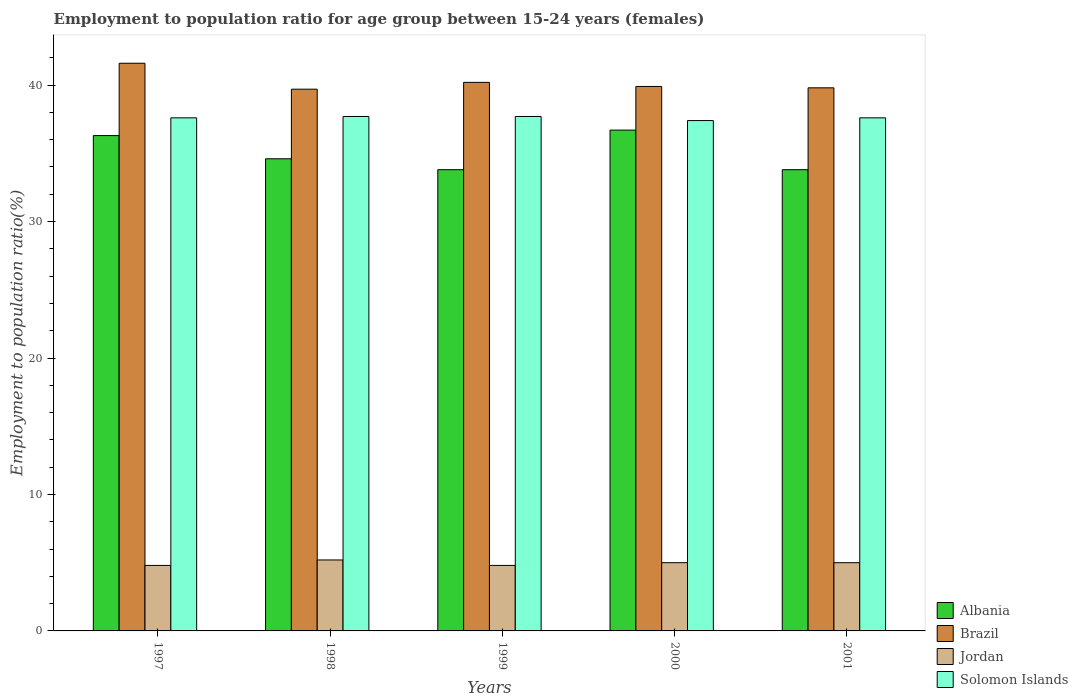How many different coloured bars are there?
Your answer should be very brief. 4. Are the number of bars per tick equal to the number of legend labels?
Your response must be concise. Yes. Are the number of bars on each tick of the X-axis equal?
Your answer should be very brief. Yes. How many bars are there on the 5th tick from the left?
Make the answer very short. 4. How many bars are there on the 3rd tick from the right?
Provide a short and direct response. 4. What is the label of the 3rd group of bars from the left?
Your answer should be compact. 1999. What is the employment to population ratio in Jordan in 1997?
Ensure brevity in your answer.  4.8. Across all years, what is the maximum employment to population ratio in Jordan?
Your answer should be very brief. 5.2. Across all years, what is the minimum employment to population ratio in Jordan?
Your answer should be compact. 4.8. In which year was the employment to population ratio in Jordan maximum?
Give a very brief answer. 1998. What is the total employment to population ratio in Brazil in the graph?
Provide a short and direct response. 201.2. What is the difference between the employment to population ratio in Jordan in 1998 and that in 2001?
Provide a short and direct response. 0.2. What is the difference between the employment to population ratio in Brazil in 2001 and the employment to population ratio in Solomon Islands in 1999?
Make the answer very short. 2.1. What is the average employment to population ratio in Jordan per year?
Offer a very short reply. 4.96. In the year 2001, what is the difference between the employment to population ratio in Jordan and employment to population ratio in Solomon Islands?
Keep it short and to the point. -32.6. What is the ratio of the employment to population ratio in Solomon Islands in 1999 to that in 2000?
Offer a terse response. 1.01. Is the difference between the employment to population ratio in Jordan in 2000 and 2001 greater than the difference between the employment to population ratio in Solomon Islands in 2000 and 2001?
Make the answer very short. Yes. What is the difference between the highest and the second highest employment to population ratio in Albania?
Offer a terse response. 0.4. What is the difference between the highest and the lowest employment to population ratio in Solomon Islands?
Provide a succinct answer. 0.3. In how many years, is the employment to population ratio in Jordan greater than the average employment to population ratio in Jordan taken over all years?
Keep it short and to the point. 3. Is it the case that in every year, the sum of the employment to population ratio in Brazil and employment to population ratio in Albania is greater than the sum of employment to population ratio in Solomon Islands and employment to population ratio in Jordan?
Provide a succinct answer. No. What does the 3rd bar from the right in 1999 represents?
Your response must be concise. Brazil. Is it the case that in every year, the sum of the employment to population ratio in Albania and employment to population ratio in Solomon Islands is greater than the employment to population ratio in Jordan?
Give a very brief answer. Yes. How many bars are there?
Ensure brevity in your answer.  20. Are all the bars in the graph horizontal?
Provide a short and direct response. No. Does the graph contain any zero values?
Provide a succinct answer. No. Does the graph contain grids?
Ensure brevity in your answer.  No. How many legend labels are there?
Ensure brevity in your answer.  4. What is the title of the graph?
Make the answer very short. Employment to population ratio for age group between 15-24 years (females). Does "Congo (Republic)" appear as one of the legend labels in the graph?
Offer a very short reply. No. What is the label or title of the Y-axis?
Provide a short and direct response. Employment to population ratio(%). What is the Employment to population ratio(%) in Albania in 1997?
Keep it short and to the point. 36.3. What is the Employment to population ratio(%) of Brazil in 1997?
Keep it short and to the point. 41.6. What is the Employment to population ratio(%) of Jordan in 1997?
Ensure brevity in your answer.  4.8. What is the Employment to population ratio(%) of Solomon Islands in 1997?
Keep it short and to the point. 37.6. What is the Employment to population ratio(%) of Albania in 1998?
Make the answer very short. 34.6. What is the Employment to population ratio(%) of Brazil in 1998?
Your response must be concise. 39.7. What is the Employment to population ratio(%) in Jordan in 1998?
Provide a succinct answer. 5.2. What is the Employment to population ratio(%) in Solomon Islands in 1998?
Ensure brevity in your answer.  37.7. What is the Employment to population ratio(%) in Albania in 1999?
Your answer should be very brief. 33.8. What is the Employment to population ratio(%) of Brazil in 1999?
Offer a very short reply. 40.2. What is the Employment to population ratio(%) of Jordan in 1999?
Provide a short and direct response. 4.8. What is the Employment to population ratio(%) of Solomon Islands in 1999?
Make the answer very short. 37.7. What is the Employment to population ratio(%) in Albania in 2000?
Provide a short and direct response. 36.7. What is the Employment to population ratio(%) of Brazil in 2000?
Make the answer very short. 39.9. What is the Employment to population ratio(%) of Jordan in 2000?
Your answer should be very brief. 5. What is the Employment to population ratio(%) of Solomon Islands in 2000?
Provide a short and direct response. 37.4. What is the Employment to population ratio(%) in Albania in 2001?
Keep it short and to the point. 33.8. What is the Employment to population ratio(%) in Brazil in 2001?
Give a very brief answer. 39.8. What is the Employment to population ratio(%) of Solomon Islands in 2001?
Provide a succinct answer. 37.6. Across all years, what is the maximum Employment to population ratio(%) of Albania?
Offer a terse response. 36.7. Across all years, what is the maximum Employment to population ratio(%) of Brazil?
Make the answer very short. 41.6. Across all years, what is the maximum Employment to population ratio(%) in Jordan?
Make the answer very short. 5.2. Across all years, what is the maximum Employment to population ratio(%) of Solomon Islands?
Make the answer very short. 37.7. Across all years, what is the minimum Employment to population ratio(%) in Albania?
Keep it short and to the point. 33.8. Across all years, what is the minimum Employment to population ratio(%) in Brazil?
Make the answer very short. 39.7. Across all years, what is the minimum Employment to population ratio(%) of Jordan?
Provide a succinct answer. 4.8. Across all years, what is the minimum Employment to population ratio(%) in Solomon Islands?
Give a very brief answer. 37.4. What is the total Employment to population ratio(%) of Albania in the graph?
Ensure brevity in your answer.  175.2. What is the total Employment to population ratio(%) in Brazil in the graph?
Provide a succinct answer. 201.2. What is the total Employment to population ratio(%) in Jordan in the graph?
Give a very brief answer. 24.8. What is the total Employment to population ratio(%) of Solomon Islands in the graph?
Provide a succinct answer. 188. What is the difference between the Employment to population ratio(%) in Albania in 1997 and that in 1998?
Ensure brevity in your answer.  1.7. What is the difference between the Employment to population ratio(%) in Brazil in 1997 and that in 1998?
Your response must be concise. 1.9. What is the difference between the Employment to population ratio(%) in Jordan in 1997 and that in 1998?
Provide a succinct answer. -0.4. What is the difference between the Employment to population ratio(%) of Solomon Islands in 1997 and that in 1998?
Keep it short and to the point. -0.1. What is the difference between the Employment to population ratio(%) in Albania in 1997 and that in 2000?
Your response must be concise. -0.4. What is the difference between the Employment to population ratio(%) of Brazil in 1997 and that in 2000?
Give a very brief answer. 1.7. What is the difference between the Employment to population ratio(%) of Jordan in 1997 and that in 2000?
Your answer should be very brief. -0.2. What is the difference between the Employment to population ratio(%) of Solomon Islands in 1997 and that in 2000?
Provide a short and direct response. 0.2. What is the difference between the Employment to population ratio(%) of Jordan in 1997 and that in 2001?
Ensure brevity in your answer.  -0.2. What is the difference between the Employment to population ratio(%) of Solomon Islands in 1997 and that in 2001?
Give a very brief answer. 0. What is the difference between the Employment to population ratio(%) in Albania in 1998 and that in 1999?
Offer a very short reply. 0.8. What is the difference between the Employment to population ratio(%) in Brazil in 1998 and that in 1999?
Your answer should be compact. -0.5. What is the difference between the Employment to population ratio(%) in Jordan in 1998 and that in 2000?
Ensure brevity in your answer.  0.2. What is the difference between the Employment to population ratio(%) of Solomon Islands in 1998 and that in 2000?
Offer a terse response. 0.3. What is the difference between the Employment to population ratio(%) of Jordan in 1998 and that in 2001?
Provide a succinct answer. 0.2. What is the difference between the Employment to population ratio(%) in Albania in 1999 and that in 2000?
Your response must be concise. -2.9. What is the difference between the Employment to population ratio(%) of Brazil in 1999 and that in 2000?
Offer a very short reply. 0.3. What is the difference between the Employment to population ratio(%) of Jordan in 1999 and that in 2000?
Offer a terse response. -0.2. What is the difference between the Employment to population ratio(%) of Solomon Islands in 1999 and that in 2000?
Your answer should be compact. 0.3. What is the difference between the Employment to population ratio(%) in Brazil in 2000 and that in 2001?
Make the answer very short. 0.1. What is the difference between the Employment to population ratio(%) of Jordan in 2000 and that in 2001?
Your answer should be compact. 0. What is the difference between the Employment to population ratio(%) in Solomon Islands in 2000 and that in 2001?
Your answer should be very brief. -0.2. What is the difference between the Employment to population ratio(%) in Albania in 1997 and the Employment to population ratio(%) in Jordan in 1998?
Keep it short and to the point. 31.1. What is the difference between the Employment to population ratio(%) of Albania in 1997 and the Employment to population ratio(%) of Solomon Islands in 1998?
Your answer should be very brief. -1.4. What is the difference between the Employment to population ratio(%) of Brazil in 1997 and the Employment to population ratio(%) of Jordan in 1998?
Offer a terse response. 36.4. What is the difference between the Employment to population ratio(%) in Jordan in 1997 and the Employment to population ratio(%) in Solomon Islands in 1998?
Provide a short and direct response. -32.9. What is the difference between the Employment to population ratio(%) in Albania in 1997 and the Employment to population ratio(%) in Brazil in 1999?
Give a very brief answer. -3.9. What is the difference between the Employment to population ratio(%) of Albania in 1997 and the Employment to population ratio(%) of Jordan in 1999?
Provide a succinct answer. 31.5. What is the difference between the Employment to population ratio(%) of Brazil in 1997 and the Employment to population ratio(%) of Jordan in 1999?
Give a very brief answer. 36.8. What is the difference between the Employment to population ratio(%) in Jordan in 1997 and the Employment to population ratio(%) in Solomon Islands in 1999?
Your response must be concise. -32.9. What is the difference between the Employment to population ratio(%) in Albania in 1997 and the Employment to population ratio(%) in Brazil in 2000?
Offer a very short reply. -3.6. What is the difference between the Employment to population ratio(%) of Albania in 1997 and the Employment to population ratio(%) of Jordan in 2000?
Provide a succinct answer. 31.3. What is the difference between the Employment to population ratio(%) of Albania in 1997 and the Employment to population ratio(%) of Solomon Islands in 2000?
Give a very brief answer. -1.1. What is the difference between the Employment to population ratio(%) in Brazil in 1997 and the Employment to population ratio(%) in Jordan in 2000?
Ensure brevity in your answer.  36.6. What is the difference between the Employment to population ratio(%) in Brazil in 1997 and the Employment to population ratio(%) in Solomon Islands in 2000?
Keep it short and to the point. 4.2. What is the difference between the Employment to population ratio(%) of Jordan in 1997 and the Employment to population ratio(%) of Solomon Islands in 2000?
Your answer should be very brief. -32.6. What is the difference between the Employment to population ratio(%) in Albania in 1997 and the Employment to population ratio(%) in Brazil in 2001?
Ensure brevity in your answer.  -3.5. What is the difference between the Employment to population ratio(%) in Albania in 1997 and the Employment to population ratio(%) in Jordan in 2001?
Offer a very short reply. 31.3. What is the difference between the Employment to population ratio(%) in Albania in 1997 and the Employment to population ratio(%) in Solomon Islands in 2001?
Provide a short and direct response. -1.3. What is the difference between the Employment to population ratio(%) of Brazil in 1997 and the Employment to population ratio(%) of Jordan in 2001?
Make the answer very short. 36.6. What is the difference between the Employment to population ratio(%) of Jordan in 1997 and the Employment to population ratio(%) of Solomon Islands in 2001?
Make the answer very short. -32.8. What is the difference between the Employment to population ratio(%) in Albania in 1998 and the Employment to population ratio(%) in Jordan in 1999?
Offer a very short reply. 29.8. What is the difference between the Employment to population ratio(%) in Albania in 1998 and the Employment to population ratio(%) in Solomon Islands in 1999?
Make the answer very short. -3.1. What is the difference between the Employment to population ratio(%) of Brazil in 1998 and the Employment to population ratio(%) of Jordan in 1999?
Provide a short and direct response. 34.9. What is the difference between the Employment to population ratio(%) of Jordan in 1998 and the Employment to population ratio(%) of Solomon Islands in 1999?
Provide a short and direct response. -32.5. What is the difference between the Employment to population ratio(%) of Albania in 1998 and the Employment to population ratio(%) of Jordan in 2000?
Make the answer very short. 29.6. What is the difference between the Employment to population ratio(%) in Brazil in 1998 and the Employment to population ratio(%) in Jordan in 2000?
Offer a very short reply. 34.7. What is the difference between the Employment to population ratio(%) of Brazil in 1998 and the Employment to population ratio(%) of Solomon Islands in 2000?
Give a very brief answer. 2.3. What is the difference between the Employment to population ratio(%) in Jordan in 1998 and the Employment to population ratio(%) in Solomon Islands in 2000?
Ensure brevity in your answer.  -32.2. What is the difference between the Employment to population ratio(%) of Albania in 1998 and the Employment to population ratio(%) of Jordan in 2001?
Your answer should be compact. 29.6. What is the difference between the Employment to population ratio(%) of Albania in 1998 and the Employment to population ratio(%) of Solomon Islands in 2001?
Give a very brief answer. -3. What is the difference between the Employment to population ratio(%) in Brazil in 1998 and the Employment to population ratio(%) in Jordan in 2001?
Offer a very short reply. 34.7. What is the difference between the Employment to population ratio(%) of Brazil in 1998 and the Employment to population ratio(%) of Solomon Islands in 2001?
Give a very brief answer. 2.1. What is the difference between the Employment to population ratio(%) in Jordan in 1998 and the Employment to population ratio(%) in Solomon Islands in 2001?
Offer a terse response. -32.4. What is the difference between the Employment to population ratio(%) in Albania in 1999 and the Employment to population ratio(%) in Jordan in 2000?
Your response must be concise. 28.8. What is the difference between the Employment to population ratio(%) in Albania in 1999 and the Employment to population ratio(%) in Solomon Islands in 2000?
Provide a succinct answer. -3.6. What is the difference between the Employment to population ratio(%) of Brazil in 1999 and the Employment to population ratio(%) of Jordan in 2000?
Your answer should be very brief. 35.2. What is the difference between the Employment to population ratio(%) of Jordan in 1999 and the Employment to population ratio(%) of Solomon Islands in 2000?
Give a very brief answer. -32.6. What is the difference between the Employment to population ratio(%) in Albania in 1999 and the Employment to population ratio(%) in Brazil in 2001?
Give a very brief answer. -6. What is the difference between the Employment to population ratio(%) in Albania in 1999 and the Employment to population ratio(%) in Jordan in 2001?
Provide a succinct answer. 28.8. What is the difference between the Employment to population ratio(%) in Brazil in 1999 and the Employment to population ratio(%) in Jordan in 2001?
Offer a terse response. 35.2. What is the difference between the Employment to population ratio(%) in Jordan in 1999 and the Employment to population ratio(%) in Solomon Islands in 2001?
Your answer should be very brief. -32.8. What is the difference between the Employment to population ratio(%) in Albania in 2000 and the Employment to population ratio(%) in Jordan in 2001?
Your answer should be compact. 31.7. What is the difference between the Employment to population ratio(%) in Albania in 2000 and the Employment to population ratio(%) in Solomon Islands in 2001?
Offer a very short reply. -0.9. What is the difference between the Employment to population ratio(%) in Brazil in 2000 and the Employment to population ratio(%) in Jordan in 2001?
Offer a terse response. 34.9. What is the difference between the Employment to population ratio(%) in Jordan in 2000 and the Employment to population ratio(%) in Solomon Islands in 2001?
Your answer should be very brief. -32.6. What is the average Employment to population ratio(%) in Albania per year?
Provide a succinct answer. 35.04. What is the average Employment to population ratio(%) of Brazil per year?
Provide a short and direct response. 40.24. What is the average Employment to population ratio(%) of Jordan per year?
Offer a terse response. 4.96. What is the average Employment to population ratio(%) in Solomon Islands per year?
Ensure brevity in your answer.  37.6. In the year 1997, what is the difference between the Employment to population ratio(%) in Albania and Employment to population ratio(%) in Jordan?
Give a very brief answer. 31.5. In the year 1997, what is the difference between the Employment to population ratio(%) in Albania and Employment to population ratio(%) in Solomon Islands?
Offer a very short reply. -1.3. In the year 1997, what is the difference between the Employment to population ratio(%) in Brazil and Employment to population ratio(%) in Jordan?
Offer a very short reply. 36.8. In the year 1997, what is the difference between the Employment to population ratio(%) of Jordan and Employment to population ratio(%) of Solomon Islands?
Give a very brief answer. -32.8. In the year 1998, what is the difference between the Employment to population ratio(%) of Albania and Employment to population ratio(%) of Jordan?
Your answer should be compact. 29.4. In the year 1998, what is the difference between the Employment to population ratio(%) of Brazil and Employment to population ratio(%) of Jordan?
Make the answer very short. 34.5. In the year 1998, what is the difference between the Employment to population ratio(%) of Brazil and Employment to population ratio(%) of Solomon Islands?
Ensure brevity in your answer.  2. In the year 1998, what is the difference between the Employment to population ratio(%) of Jordan and Employment to population ratio(%) of Solomon Islands?
Provide a short and direct response. -32.5. In the year 1999, what is the difference between the Employment to population ratio(%) in Albania and Employment to population ratio(%) in Brazil?
Make the answer very short. -6.4. In the year 1999, what is the difference between the Employment to population ratio(%) of Albania and Employment to population ratio(%) of Jordan?
Your answer should be very brief. 29. In the year 1999, what is the difference between the Employment to population ratio(%) of Brazil and Employment to population ratio(%) of Jordan?
Give a very brief answer. 35.4. In the year 1999, what is the difference between the Employment to population ratio(%) of Brazil and Employment to population ratio(%) of Solomon Islands?
Your answer should be compact. 2.5. In the year 1999, what is the difference between the Employment to population ratio(%) in Jordan and Employment to population ratio(%) in Solomon Islands?
Provide a short and direct response. -32.9. In the year 2000, what is the difference between the Employment to population ratio(%) of Albania and Employment to population ratio(%) of Brazil?
Make the answer very short. -3.2. In the year 2000, what is the difference between the Employment to population ratio(%) in Albania and Employment to population ratio(%) in Jordan?
Make the answer very short. 31.7. In the year 2000, what is the difference between the Employment to population ratio(%) in Brazil and Employment to population ratio(%) in Jordan?
Your answer should be very brief. 34.9. In the year 2000, what is the difference between the Employment to population ratio(%) in Jordan and Employment to population ratio(%) in Solomon Islands?
Keep it short and to the point. -32.4. In the year 2001, what is the difference between the Employment to population ratio(%) of Albania and Employment to population ratio(%) of Jordan?
Offer a very short reply. 28.8. In the year 2001, what is the difference between the Employment to population ratio(%) in Albania and Employment to population ratio(%) in Solomon Islands?
Ensure brevity in your answer.  -3.8. In the year 2001, what is the difference between the Employment to population ratio(%) in Brazil and Employment to population ratio(%) in Jordan?
Keep it short and to the point. 34.8. In the year 2001, what is the difference between the Employment to population ratio(%) in Brazil and Employment to population ratio(%) in Solomon Islands?
Ensure brevity in your answer.  2.2. In the year 2001, what is the difference between the Employment to population ratio(%) in Jordan and Employment to population ratio(%) in Solomon Islands?
Offer a very short reply. -32.6. What is the ratio of the Employment to population ratio(%) of Albania in 1997 to that in 1998?
Your answer should be very brief. 1.05. What is the ratio of the Employment to population ratio(%) in Brazil in 1997 to that in 1998?
Ensure brevity in your answer.  1.05. What is the ratio of the Employment to population ratio(%) of Jordan in 1997 to that in 1998?
Your response must be concise. 0.92. What is the ratio of the Employment to population ratio(%) in Solomon Islands in 1997 to that in 1998?
Provide a short and direct response. 1. What is the ratio of the Employment to population ratio(%) in Albania in 1997 to that in 1999?
Make the answer very short. 1.07. What is the ratio of the Employment to population ratio(%) of Brazil in 1997 to that in 1999?
Provide a succinct answer. 1.03. What is the ratio of the Employment to population ratio(%) of Albania in 1997 to that in 2000?
Your answer should be compact. 0.99. What is the ratio of the Employment to population ratio(%) in Brazil in 1997 to that in 2000?
Offer a terse response. 1.04. What is the ratio of the Employment to population ratio(%) in Solomon Islands in 1997 to that in 2000?
Give a very brief answer. 1.01. What is the ratio of the Employment to population ratio(%) in Albania in 1997 to that in 2001?
Ensure brevity in your answer.  1.07. What is the ratio of the Employment to population ratio(%) of Brazil in 1997 to that in 2001?
Offer a very short reply. 1.05. What is the ratio of the Employment to population ratio(%) of Jordan in 1997 to that in 2001?
Your answer should be very brief. 0.96. What is the ratio of the Employment to population ratio(%) in Albania in 1998 to that in 1999?
Keep it short and to the point. 1.02. What is the ratio of the Employment to population ratio(%) of Brazil in 1998 to that in 1999?
Give a very brief answer. 0.99. What is the ratio of the Employment to population ratio(%) in Jordan in 1998 to that in 1999?
Provide a succinct answer. 1.08. What is the ratio of the Employment to population ratio(%) of Albania in 1998 to that in 2000?
Provide a short and direct response. 0.94. What is the ratio of the Employment to population ratio(%) of Brazil in 1998 to that in 2000?
Keep it short and to the point. 0.99. What is the ratio of the Employment to population ratio(%) in Jordan in 1998 to that in 2000?
Your response must be concise. 1.04. What is the ratio of the Employment to population ratio(%) in Solomon Islands in 1998 to that in 2000?
Offer a terse response. 1.01. What is the ratio of the Employment to population ratio(%) of Albania in 1998 to that in 2001?
Your response must be concise. 1.02. What is the ratio of the Employment to population ratio(%) of Brazil in 1998 to that in 2001?
Offer a very short reply. 1. What is the ratio of the Employment to population ratio(%) in Solomon Islands in 1998 to that in 2001?
Offer a very short reply. 1. What is the ratio of the Employment to population ratio(%) of Albania in 1999 to that in 2000?
Make the answer very short. 0.92. What is the ratio of the Employment to population ratio(%) of Brazil in 1999 to that in 2000?
Make the answer very short. 1.01. What is the ratio of the Employment to population ratio(%) of Jordan in 1999 to that in 2000?
Provide a short and direct response. 0.96. What is the ratio of the Employment to population ratio(%) in Solomon Islands in 1999 to that in 2000?
Make the answer very short. 1.01. What is the ratio of the Employment to population ratio(%) of Brazil in 1999 to that in 2001?
Make the answer very short. 1.01. What is the ratio of the Employment to population ratio(%) of Jordan in 1999 to that in 2001?
Offer a very short reply. 0.96. What is the ratio of the Employment to population ratio(%) in Albania in 2000 to that in 2001?
Keep it short and to the point. 1.09. What is the ratio of the Employment to population ratio(%) of Brazil in 2000 to that in 2001?
Provide a succinct answer. 1. What is the ratio of the Employment to population ratio(%) in Solomon Islands in 2000 to that in 2001?
Your response must be concise. 0.99. What is the difference between the highest and the lowest Employment to population ratio(%) in Brazil?
Your answer should be compact. 1.9. What is the difference between the highest and the lowest Employment to population ratio(%) of Jordan?
Give a very brief answer. 0.4. 